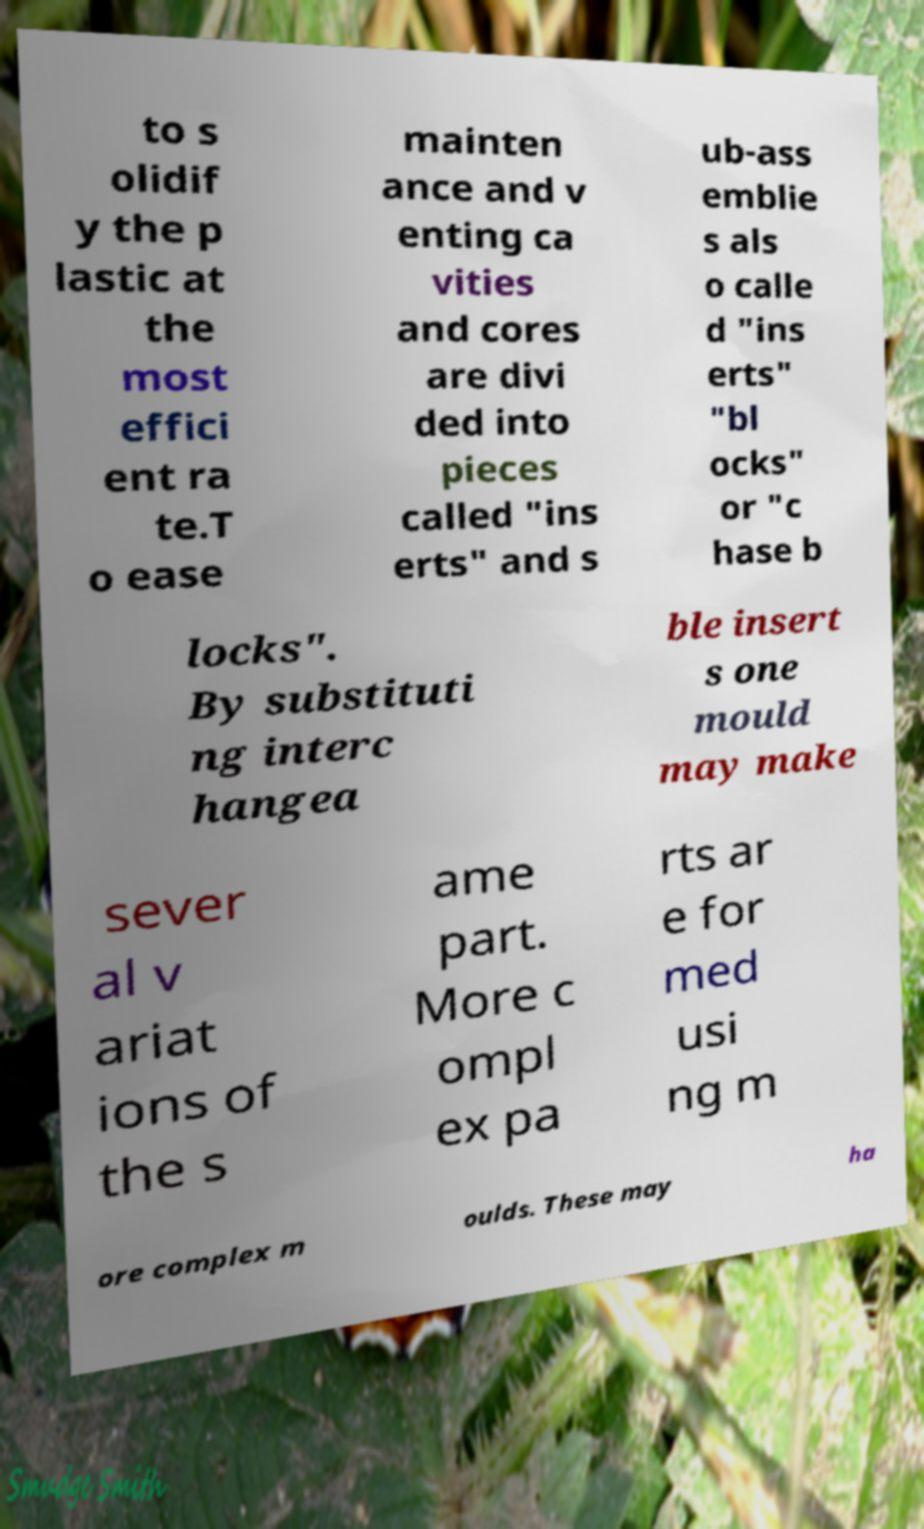For documentation purposes, I need the text within this image transcribed. Could you provide that? to s olidif y the p lastic at the most effici ent ra te.T o ease mainten ance and v enting ca vities and cores are divi ded into pieces called "ins erts" and s ub-ass emblie s als o calle d "ins erts" "bl ocks" or "c hase b locks". By substituti ng interc hangea ble insert s one mould may make sever al v ariat ions of the s ame part. More c ompl ex pa rts ar e for med usi ng m ore complex m oulds. These may ha 